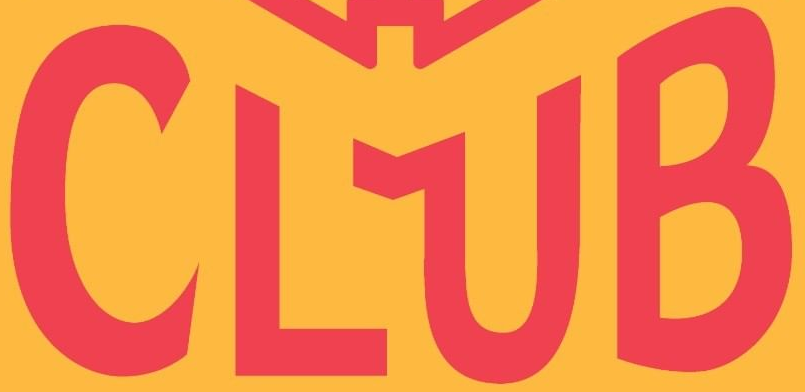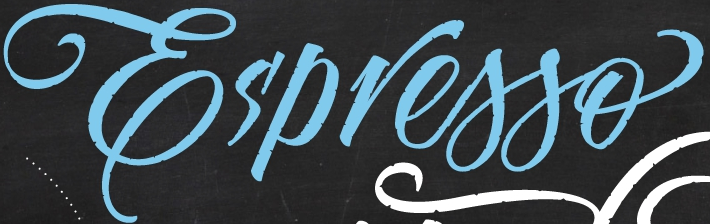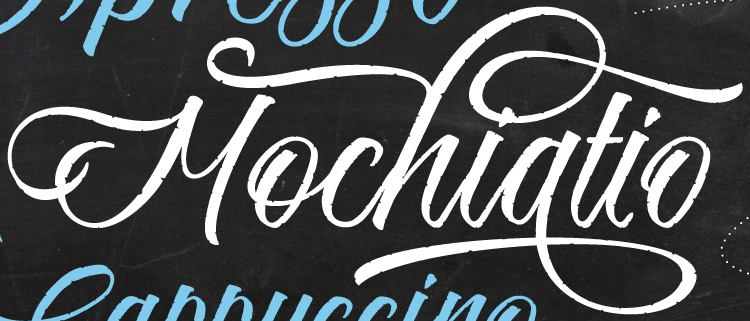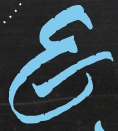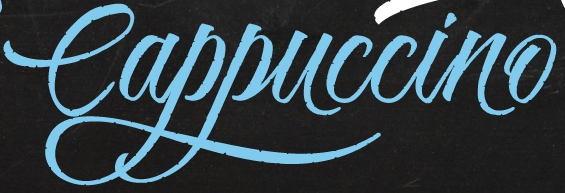What text appears in these images from left to right, separated by a semicolon? CLUB; Es'presso; Mochiatio; E; Cappuccino 